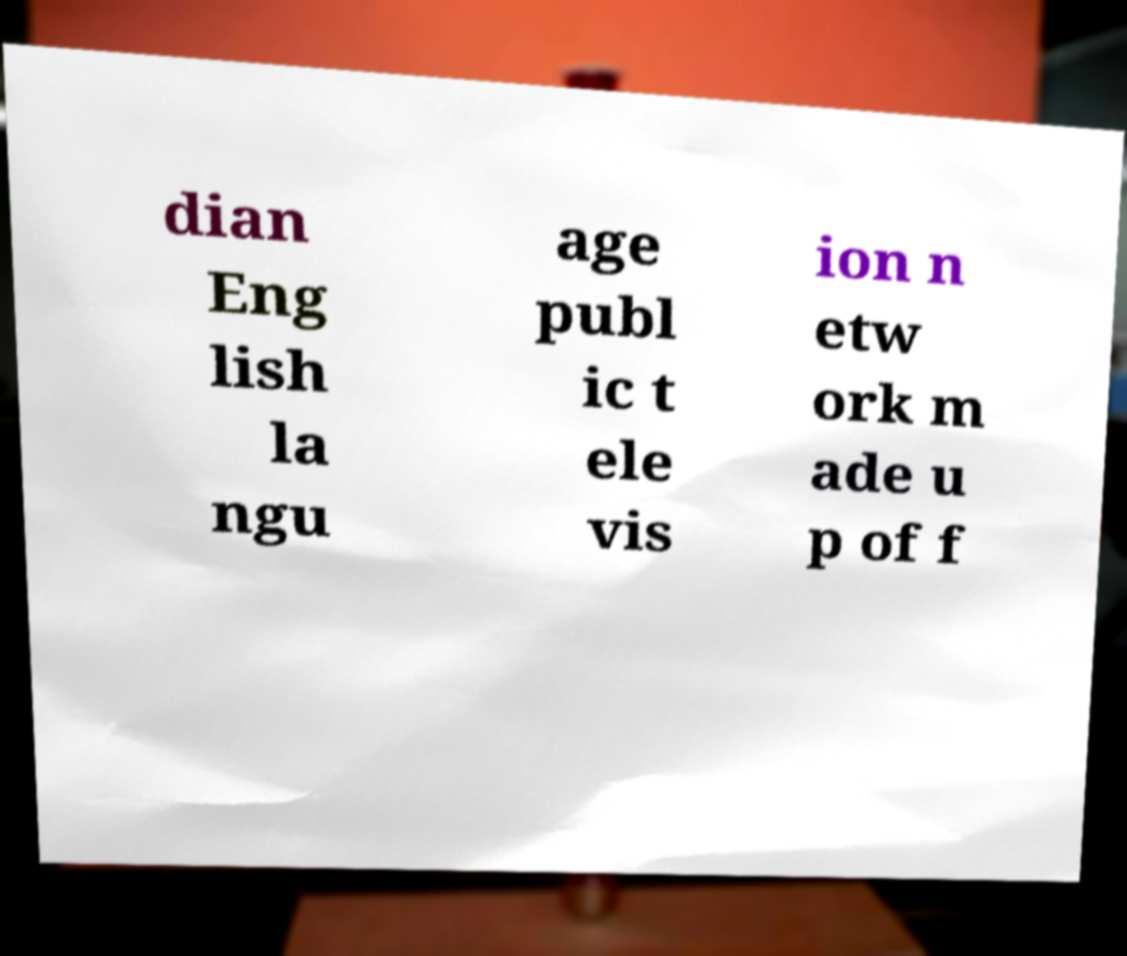What messages or text are displayed in this image? I need them in a readable, typed format. dian Eng lish la ngu age publ ic t ele vis ion n etw ork m ade u p of f 